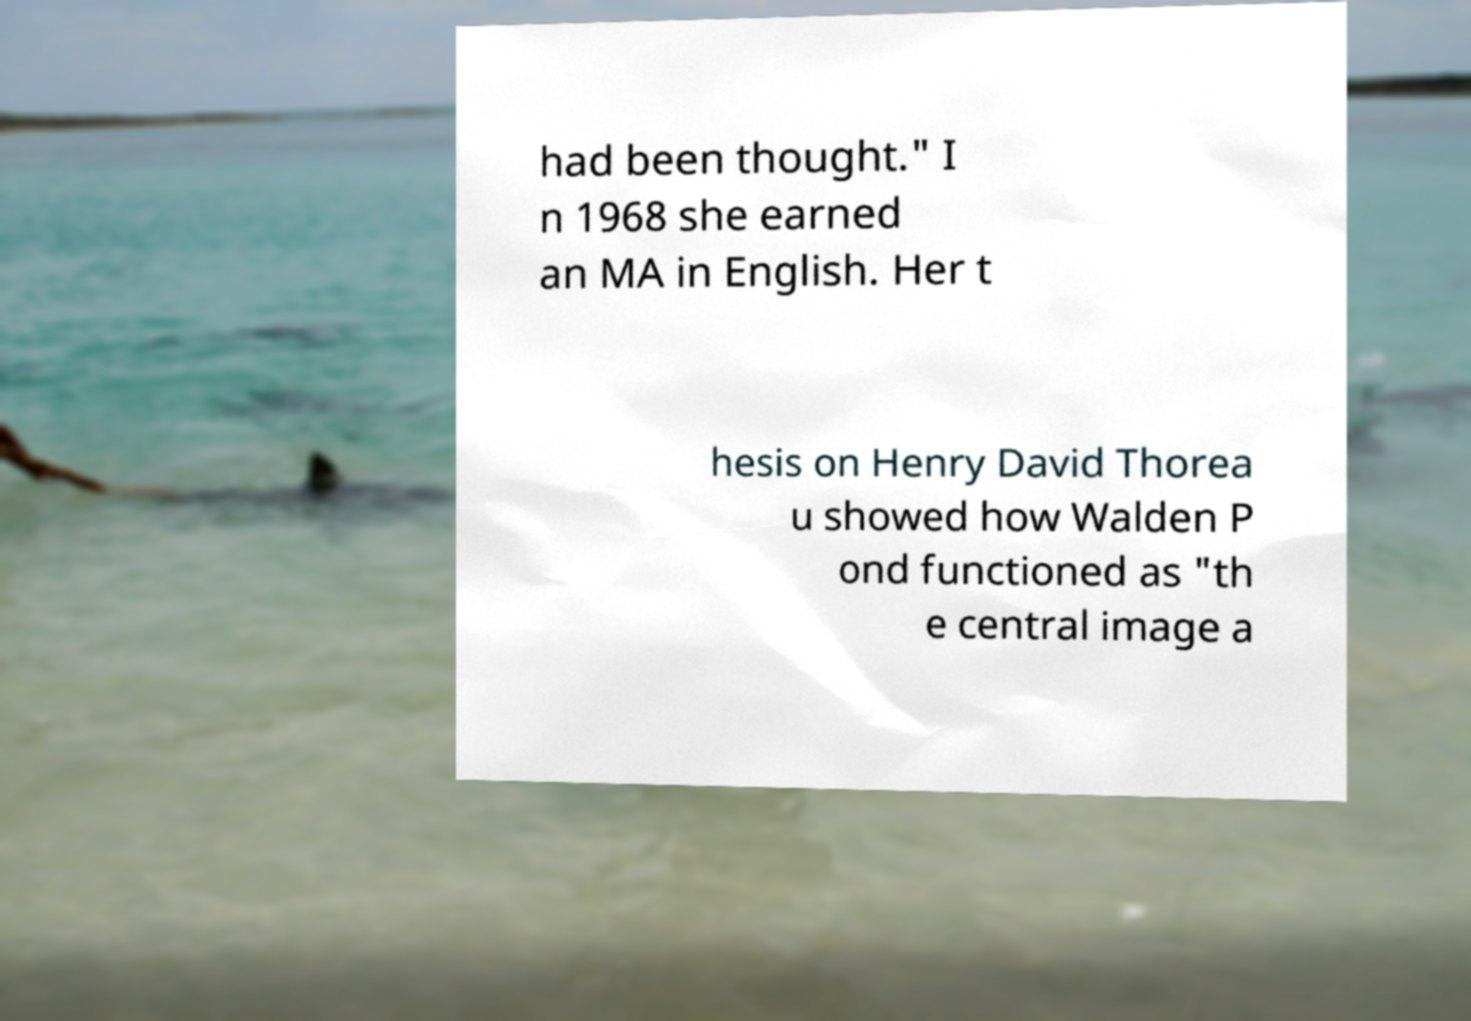For documentation purposes, I need the text within this image transcribed. Could you provide that? had been thought." I n 1968 she earned an MA in English. Her t hesis on Henry David Thorea u showed how Walden P ond functioned as "th e central image a 